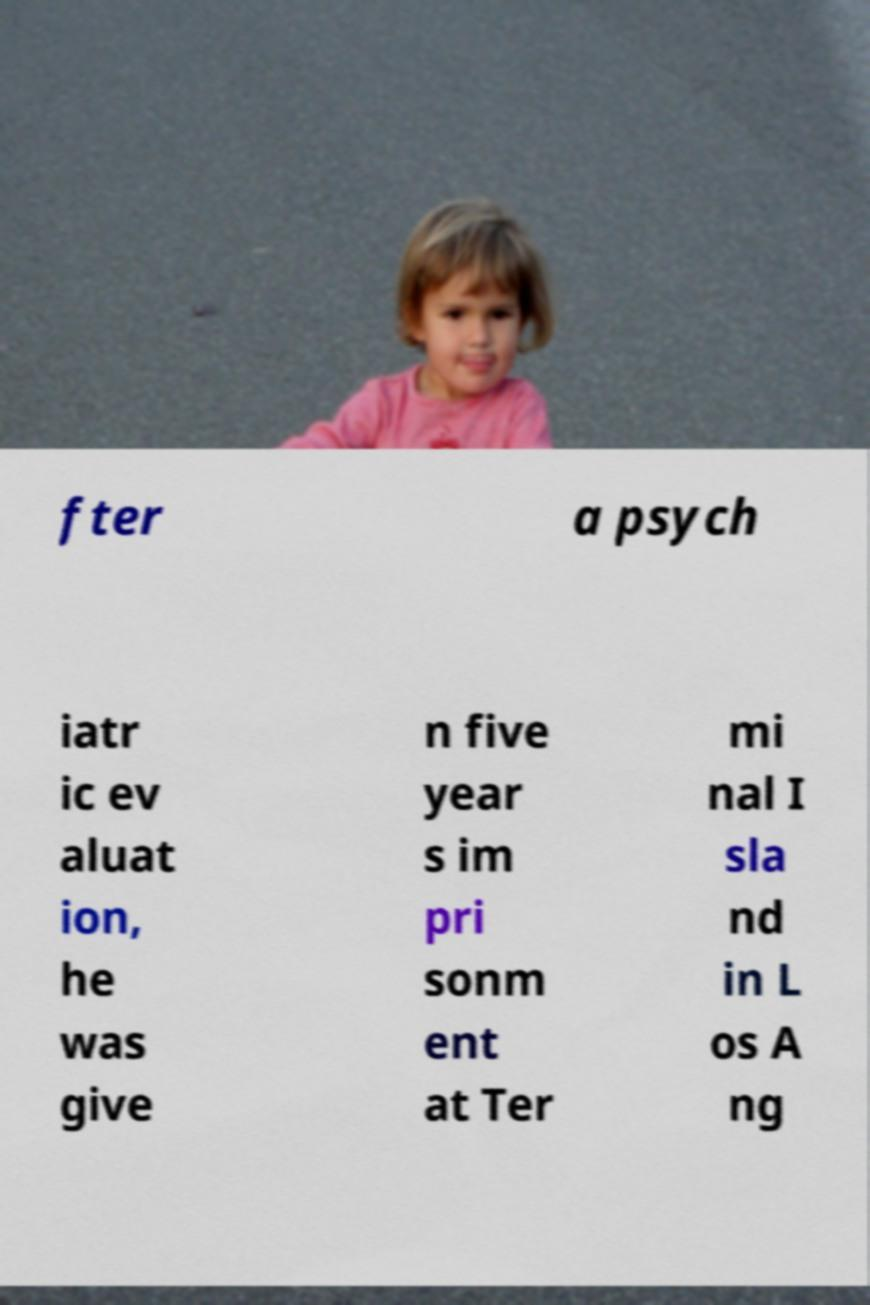Please identify and transcribe the text found in this image. fter a psych iatr ic ev aluat ion, he was give n five year s im pri sonm ent at Ter mi nal I sla nd in L os A ng 